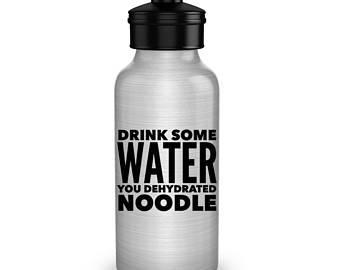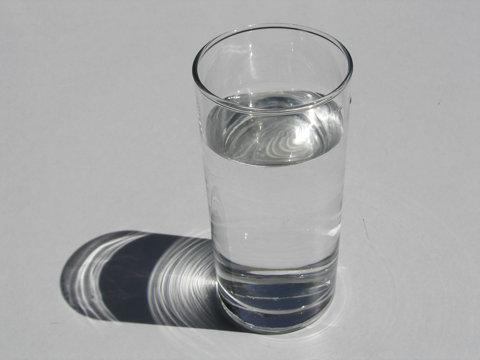The first image is the image on the left, the second image is the image on the right. Assess this claim about the two images: "One of the bottles is closed and has a straw down the middle, a loop on the side, and a trigger on the opposite side.". Correct or not? Answer yes or no. No. The first image is the image on the left, the second image is the image on the right. Examine the images to the left and right. Is the description "There are exactly two bottles." accurate? Answer yes or no. No. 